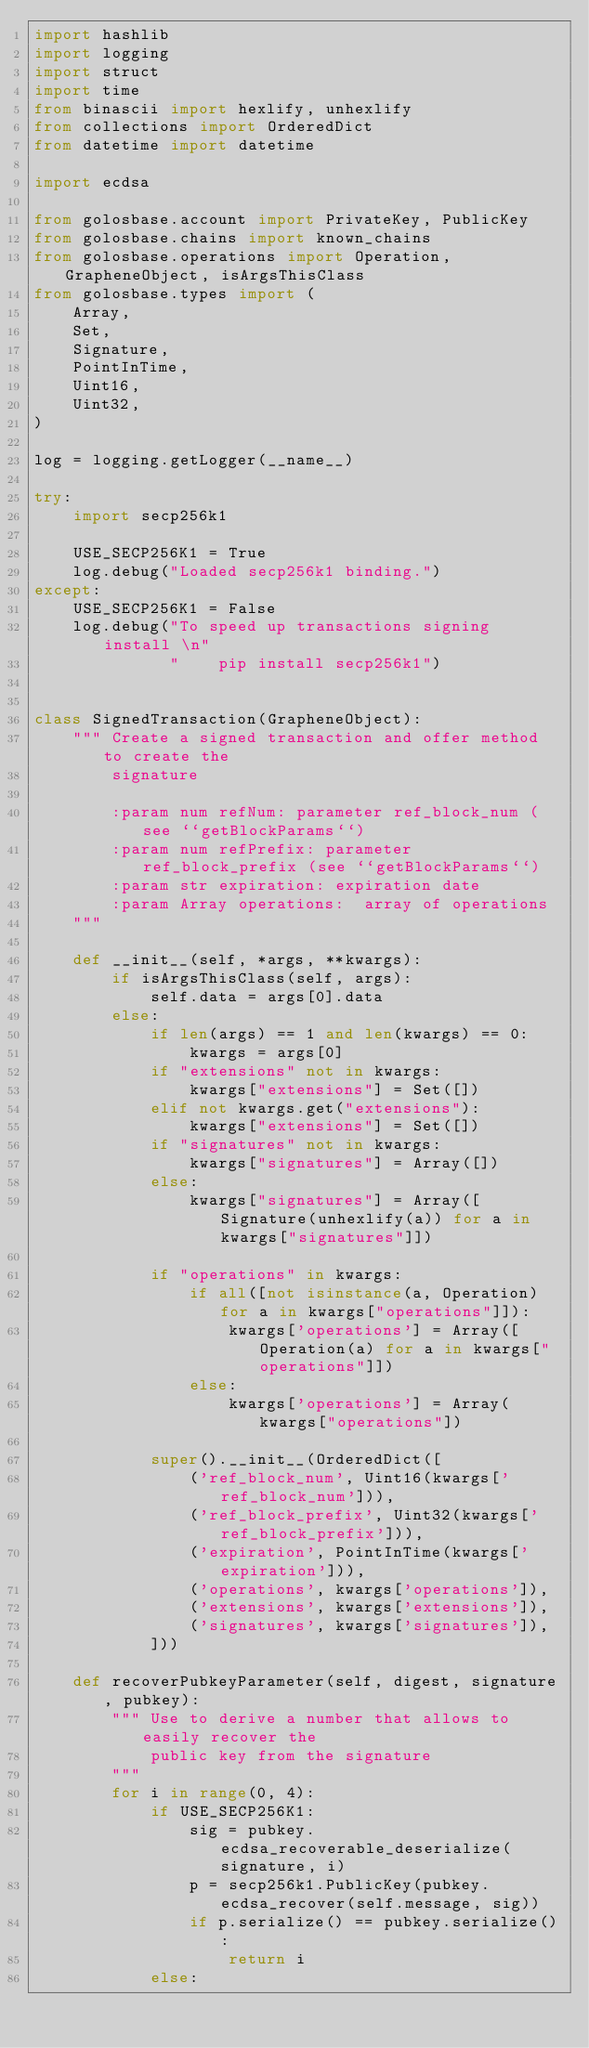<code> <loc_0><loc_0><loc_500><loc_500><_Python_>import hashlib
import logging
import struct
import time
from binascii import hexlify, unhexlify
from collections import OrderedDict
from datetime import datetime

import ecdsa

from golosbase.account import PrivateKey, PublicKey
from golosbase.chains import known_chains
from golosbase.operations import Operation, GrapheneObject, isArgsThisClass
from golosbase.types import (
    Array,
    Set,
    Signature,
    PointInTime,
    Uint16,
    Uint32,
)

log = logging.getLogger(__name__)

try:
    import secp256k1

    USE_SECP256K1 = True
    log.debug("Loaded secp256k1 binding.")
except:
    USE_SECP256K1 = False
    log.debug("To speed up transactions signing install \n"
              "    pip install secp256k1")


class SignedTransaction(GrapheneObject):
    """ Create a signed transaction and offer method to create the
        signature

        :param num refNum: parameter ref_block_num (see ``getBlockParams``)
        :param num refPrefix: parameter ref_block_prefix (see ``getBlockParams``)
        :param str expiration: expiration date
        :param Array operations:  array of operations
    """

    def __init__(self, *args, **kwargs):
        if isArgsThisClass(self, args):
            self.data = args[0].data
        else:
            if len(args) == 1 and len(kwargs) == 0:
                kwargs = args[0]
            if "extensions" not in kwargs:
                kwargs["extensions"] = Set([])
            elif not kwargs.get("extensions"):
                kwargs["extensions"] = Set([])
            if "signatures" not in kwargs:
                kwargs["signatures"] = Array([])
            else:
                kwargs["signatures"] = Array([Signature(unhexlify(a)) for a in kwargs["signatures"]])

            if "operations" in kwargs:
                if all([not isinstance(a, Operation) for a in kwargs["operations"]]):
                    kwargs['operations'] = Array([Operation(a) for a in kwargs["operations"]])
                else:
                    kwargs['operations'] = Array(kwargs["operations"])

            super().__init__(OrderedDict([
                ('ref_block_num', Uint16(kwargs['ref_block_num'])),
                ('ref_block_prefix', Uint32(kwargs['ref_block_prefix'])),
                ('expiration', PointInTime(kwargs['expiration'])),
                ('operations', kwargs['operations']),
                ('extensions', kwargs['extensions']),
                ('signatures', kwargs['signatures']),
            ]))

    def recoverPubkeyParameter(self, digest, signature, pubkey):
        """ Use to derive a number that allows to easily recover the
            public key from the signature
        """
        for i in range(0, 4):
            if USE_SECP256K1:
                sig = pubkey.ecdsa_recoverable_deserialize(signature, i)
                p = secp256k1.PublicKey(pubkey.ecdsa_recover(self.message, sig))
                if p.serialize() == pubkey.serialize():
                    return i
            else:</code> 